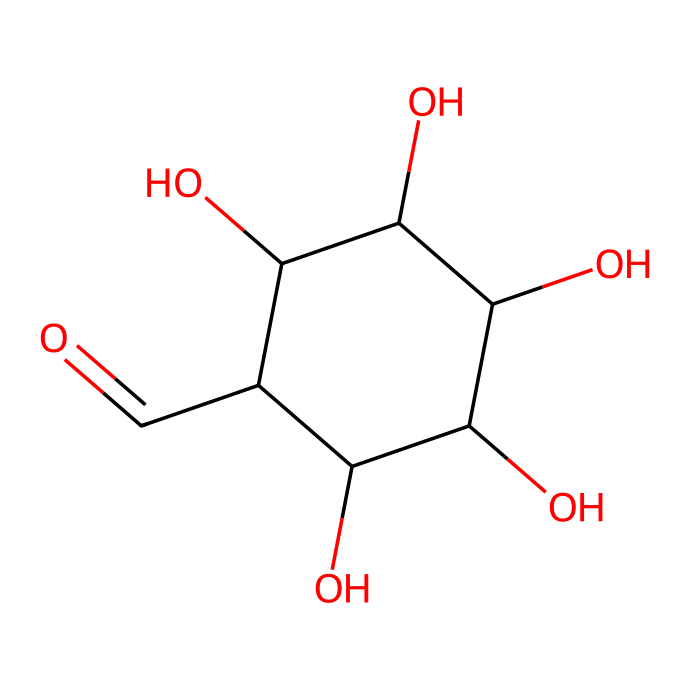What is the name of this chemical? The chemical structure provided corresponds to glucose, which is a simple sugar and an important carbohydrate in biology. It can be identified through the arrangement of its atoms and the presence of functional groups, such as the aldehyde group.
Answer: glucose How many oxygen atoms are present in this molecule? By analyzing the SMILES representation and counting the oxygen atoms in the structure, we find that there are five oxygen atoms present, including the aldehyde functional group.
Answer: five Is this chemical an aldehyde or a ketone? The presence of the aldehyde functional group (-CHO) at the end of the carbon chain indicates that this chemical is classified as an aldehyde rather than a ketone.
Answer: aldehyde What functional group is present in glucose? The structure shows the presence of a carbonyl group due to the aldehyde functional group at one end, which is characteristic of aldehydes.
Answer: aldehyde How many carbon atoms are in this molecule? By counting the carbon atoms indicated in the SMILES representation, there are six carbon atoms in total, which is typical for glucose.
Answer: six Which part of this molecule is responsible for energy storage? The multiple hydroxyl groups (-OH) in the structure make glucose capable of forming a stable cyclic structure. These groups allow for energy storage through glycosidic linkages when forming polysaccharides.
Answer: hydroxyl groups 